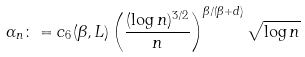<formula> <loc_0><loc_0><loc_500><loc_500>\alpha _ { n } \colon = c _ { 6 } ( \beta , L ) \left ( \frac { ( \log n ) ^ { 3 / 2 } } { n } \right ) ^ { { \beta } / { ( \beta + d ) } } \sqrt { \log n }</formula> 